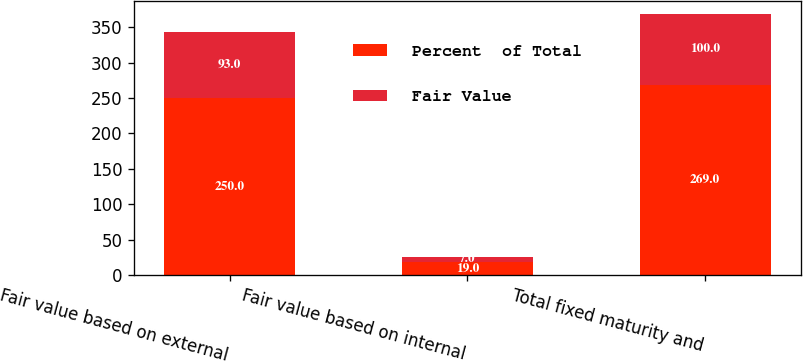Convert chart. <chart><loc_0><loc_0><loc_500><loc_500><stacked_bar_chart><ecel><fcel>Fair value based on external<fcel>Fair value based on internal<fcel>Total fixed maturity and<nl><fcel>Percent  of Total<fcel>250<fcel>19<fcel>269<nl><fcel>Fair Value<fcel>93<fcel>7<fcel>100<nl></chart> 